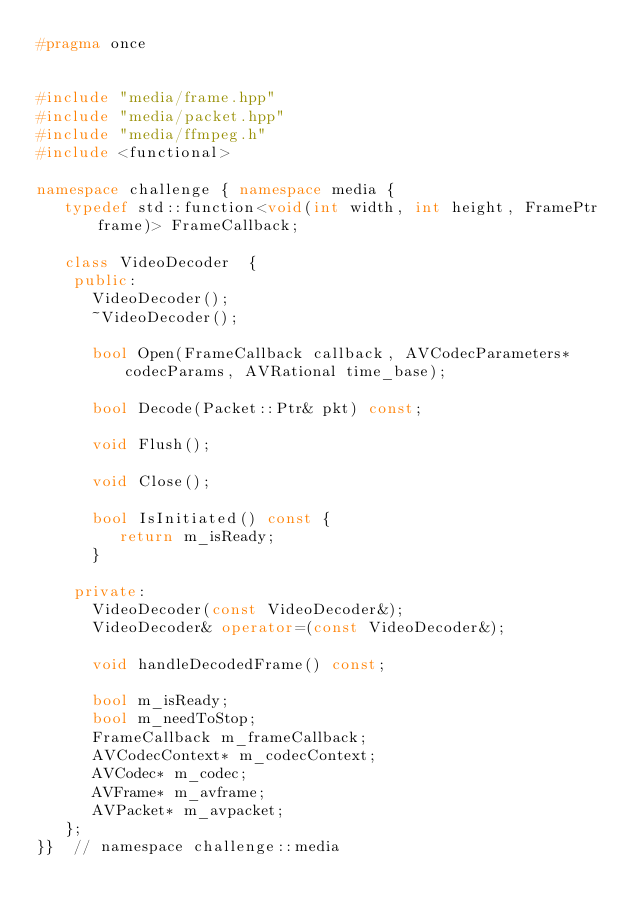<code> <loc_0><loc_0><loc_500><loc_500><_C++_>#pragma once


#include "media/frame.hpp"
#include "media/packet.hpp"
#include "media/ffmpeg.h"
#include <functional>

namespace challenge { namespace media {
   typedef std::function<void(int width, int height, FramePtr frame)> FrameCallback;

   class VideoDecoder  {
    public:
      VideoDecoder();
      ~VideoDecoder();

      bool Open(FrameCallback callback, AVCodecParameters* codecParams, AVRational time_base);

      bool Decode(Packet::Ptr& pkt) const;

      void Flush();

      void Close();

      bool IsInitiated() const {
         return m_isReady;
      }

    private:
      VideoDecoder(const VideoDecoder&);
      VideoDecoder& operator=(const VideoDecoder&);

      void handleDecodedFrame() const;

      bool m_isReady;
      bool m_needToStop;
      FrameCallback m_frameCallback;
      AVCodecContext* m_codecContext;
      AVCodec* m_codec;
      AVFrame* m_avframe;
      AVPacket* m_avpacket;
   };
}}  // namespace challenge::media
</code> 